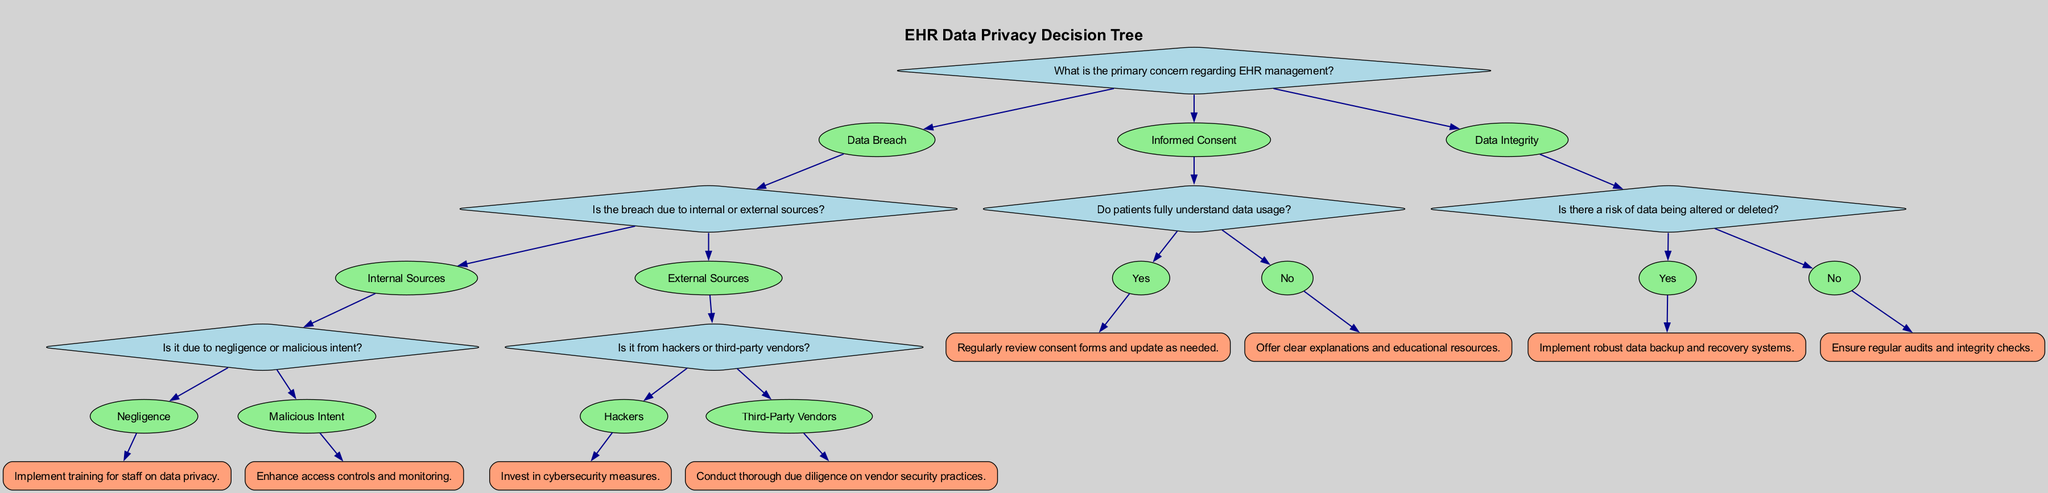What is the primary concern in EHR management? The diagram shows that the root question is about the primary concern regarding EHR management, with options including "Data Breach", "Informed Consent", and "Data Integrity".
Answer: Data Breach How many main options are there under the primary concern? The diagram presents three main options branching from the primary concern: "Data Breach", "Informed Consent", and "Data Integrity". Counting these options gives a total of three.
Answer: 3 What is the result if the breach is due to internal sources and negligence? According to the diagram, if the breach is attributed to internal sources and is due to negligence, the next action is to implement training for staff on data privacy.
Answer: Implement training for staff on data privacy What action is recommended for a breach caused by hackers? The diagram specifies that if the breach is caused by hackers, the recommended action is to invest in cybersecurity measures.
Answer: Invest in cybersecurity measures What should be done if patients do not understand data usage? Referring to the diagram, if patients do not fully understand data usage, it suggests offering clear explanations and educational resources.
Answer: Offer clear explanations and educational resources What leads to the recommendation of conducting due diligence on vendor security practices? The flow in the diagram outlines that if a data breach is from external sources and specifically from third-party vendors, it leads to the recommendation to conduct thorough due diligence on vendor security practices.
Answer: Conduct thorough due diligence on vendor security practices Is data integrity a concern in the case of data not being altered or deleted? The diagram indicates that there is no risk of data being altered or deleted; therefore, the action is to ensure regular audits and integrity checks.
Answer: Ensure regular audits and integrity checks What is the outcome if patients fully understand data usage? If patients fully understand data usage, the diagram states that the next step is to regularly review consent forms and update as needed.
Answer: Regularly review consent forms and update as needed 